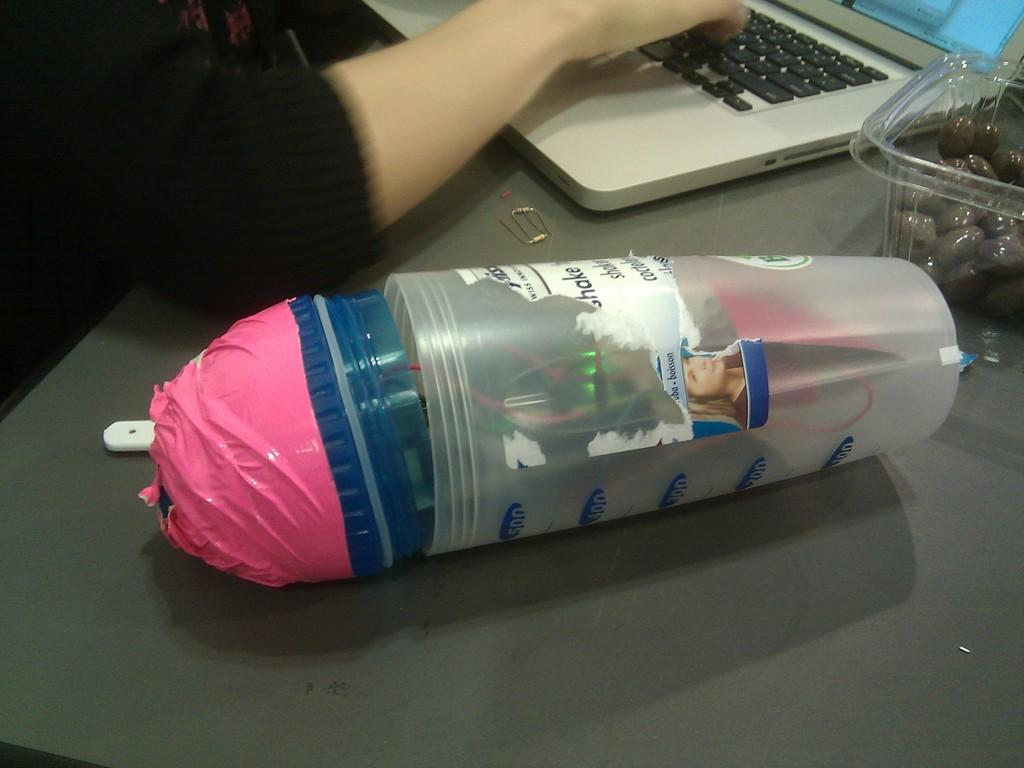<image>
Provide a brief description of the given image. Woman using laptop next to a bottle which says Shake. 